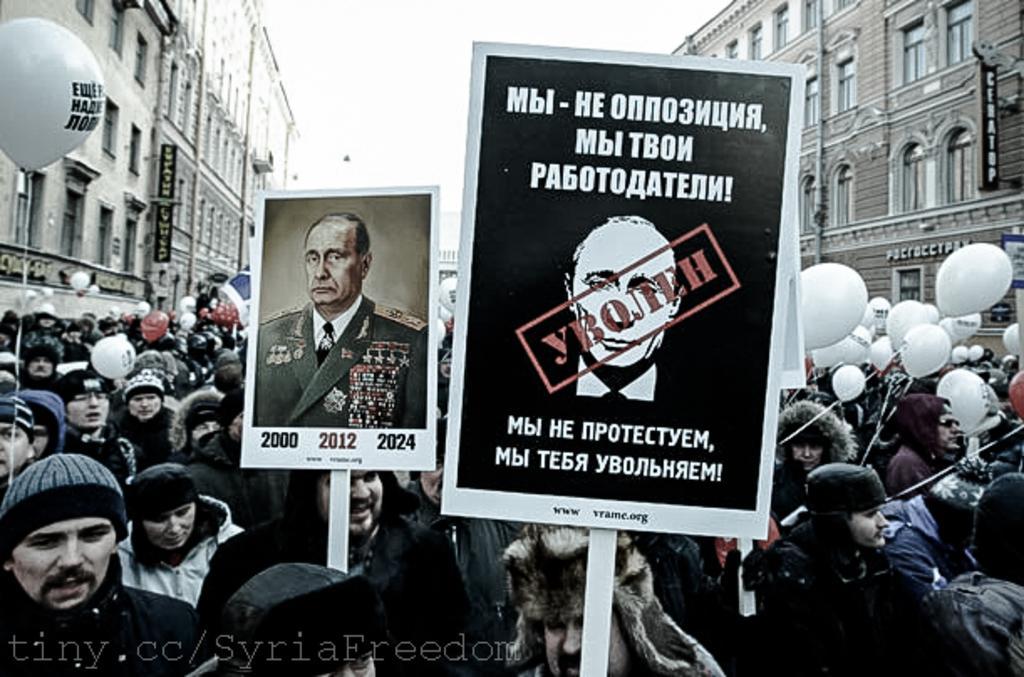Describe this image in one or two sentences. In this image I can see number of people are standing. I can see all of them are wearing caps and jackets and I can see most of them are holding white balloons. In the front I can see two boards and on one board I can see a picture of a man and I can also see something is written on these boards. On the both sides of the image I can see few buildings, few boards and on these boards I can see also see something is written. On the bottom left side of the image I can see a watermark. 